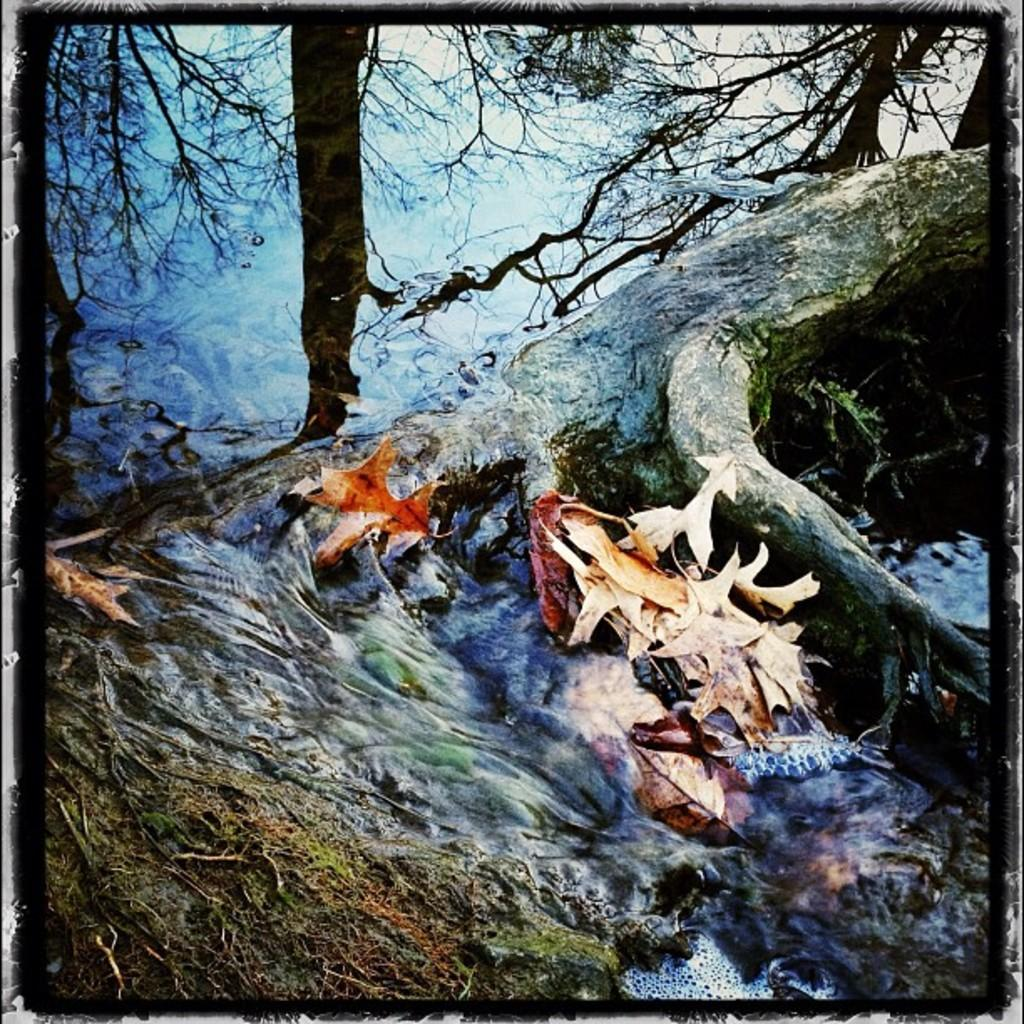What type of vegetation can be seen in the image? There are trees in the image. What natural element is visible in the image? There is water visible in the image. What color are the leaves on the trees in the image? The leaves on the trees in the image are brown. What colors are present in the background of the image? The background of the image is blue and white. What type of meat is being cooked in the image? There is no meat present in the image; it features trees, water, and brown leaves. What substance is being written in the image? There is no writing or substance being written in the image. 